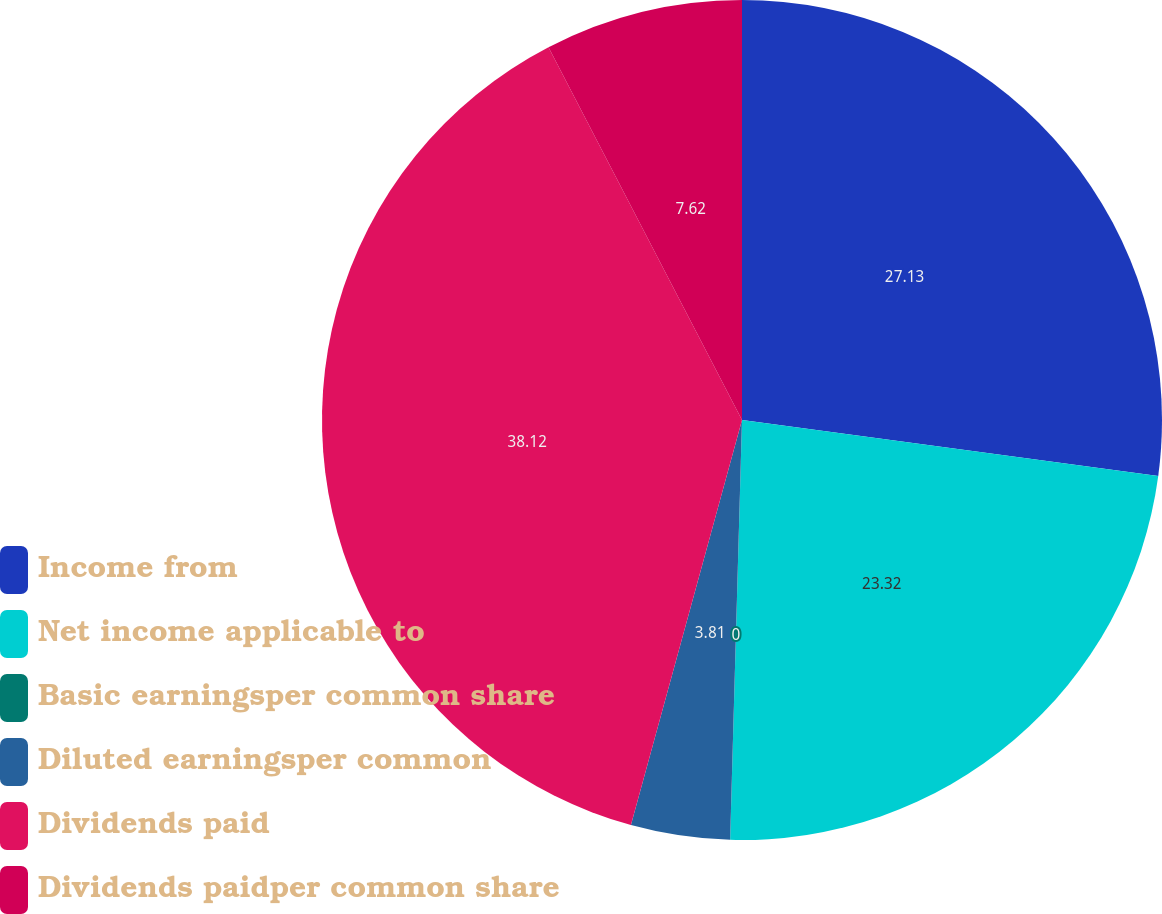Convert chart to OTSL. <chart><loc_0><loc_0><loc_500><loc_500><pie_chart><fcel>Income from<fcel>Net income applicable to<fcel>Basic earningsper common share<fcel>Diluted earningsper common<fcel>Dividends paid<fcel>Dividends paidper common share<nl><fcel>27.13%<fcel>23.32%<fcel>0.0%<fcel>3.81%<fcel>38.12%<fcel>7.62%<nl></chart> 